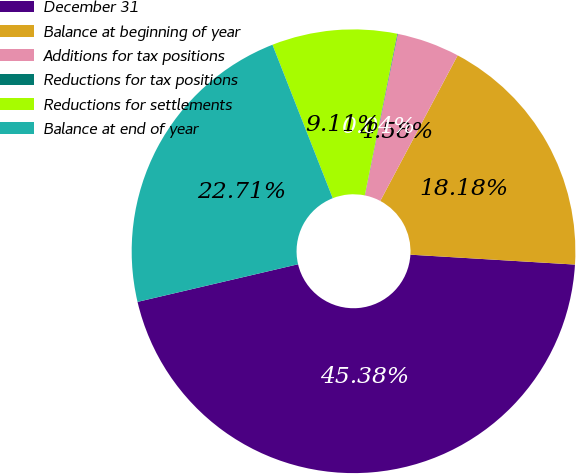Convert chart to OTSL. <chart><loc_0><loc_0><loc_500><loc_500><pie_chart><fcel>December 31<fcel>Balance at beginning of year<fcel>Additions for tax positions<fcel>Reductions for tax positions<fcel>Reductions for settlements<fcel>Balance at end of year<nl><fcel>45.38%<fcel>18.18%<fcel>4.58%<fcel>0.04%<fcel>9.11%<fcel>22.71%<nl></chart> 